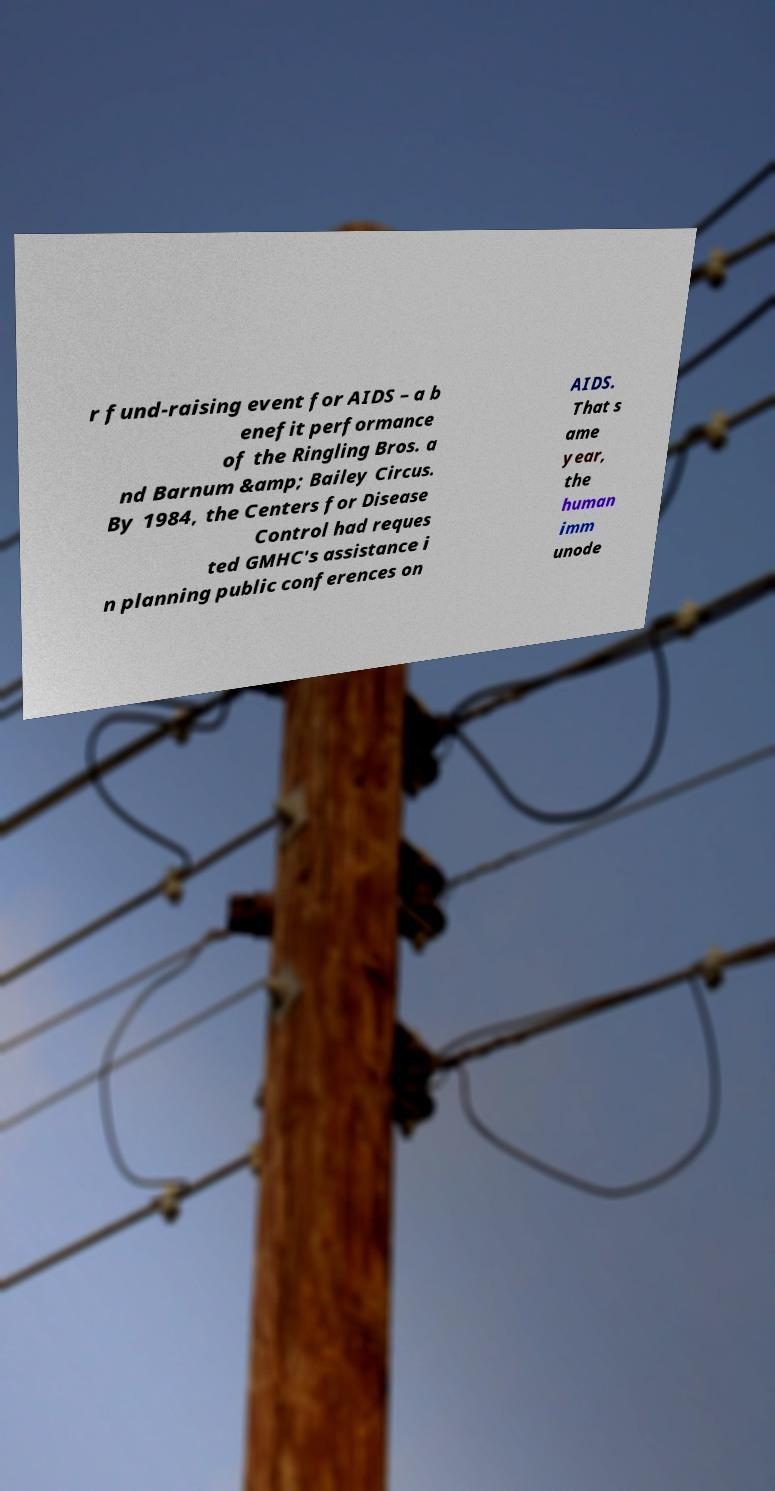Can you accurately transcribe the text from the provided image for me? r fund-raising event for AIDS – a b enefit performance of the Ringling Bros. a nd Barnum &amp; Bailey Circus. By 1984, the Centers for Disease Control had reques ted GMHC's assistance i n planning public conferences on AIDS. That s ame year, the human imm unode 